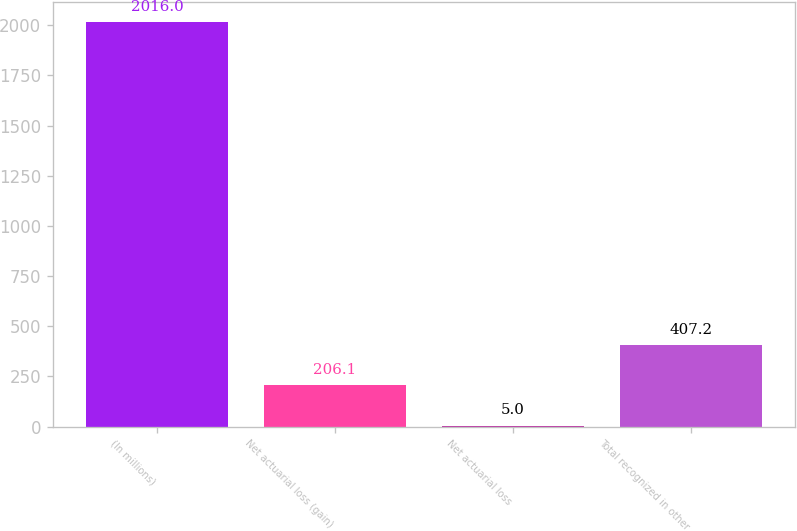<chart> <loc_0><loc_0><loc_500><loc_500><bar_chart><fcel>(In millions)<fcel>Net actuarial loss (gain)<fcel>Net actuarial loss<fcel>Total recognized in other<nl><fcel>2016<fcel>206.1<fcel>5<fcel>407.2<nl></chart> 